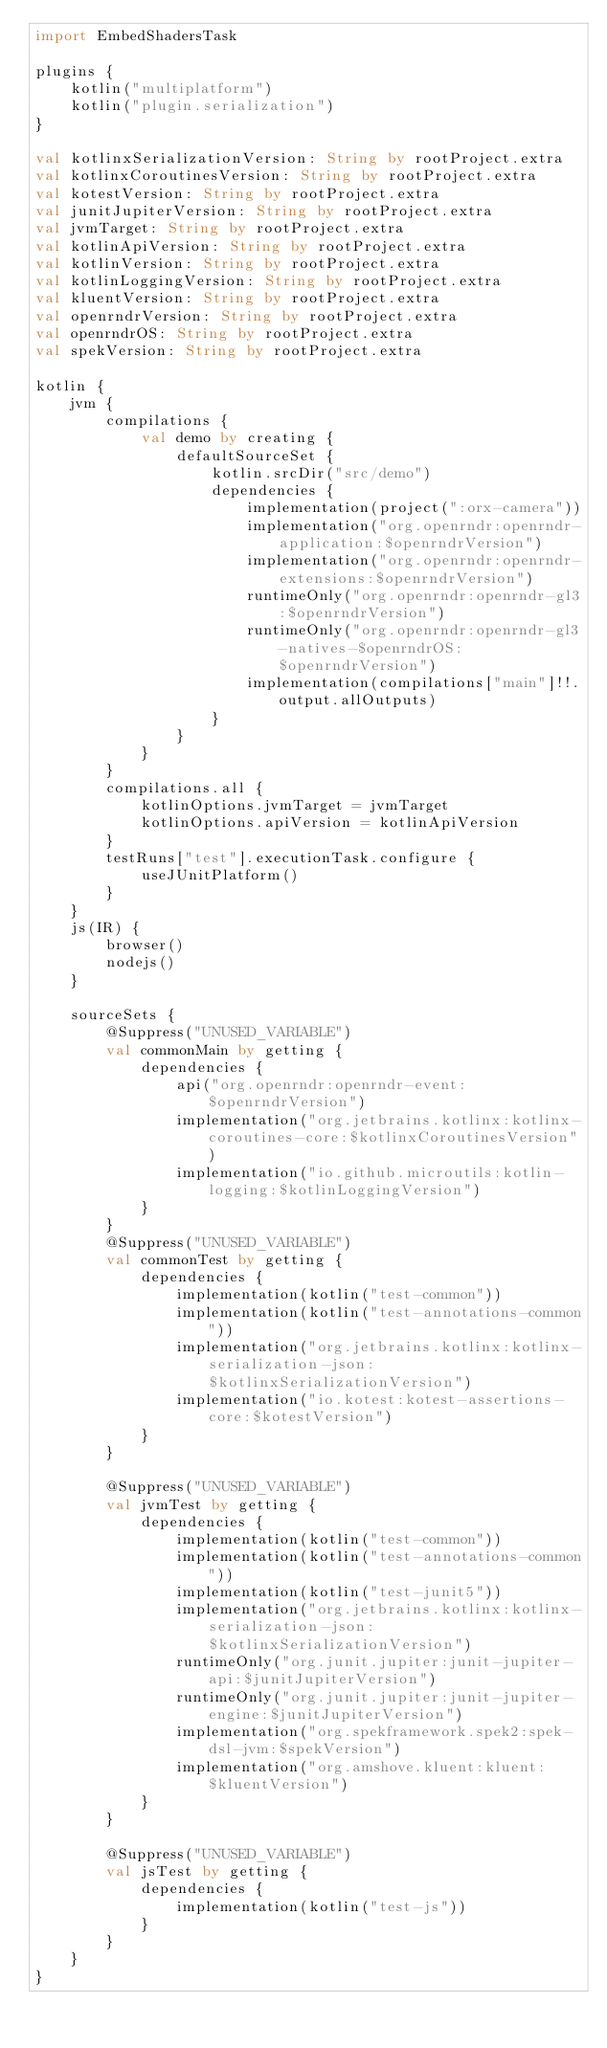<code> <loc_0><loc_0><loc_500><loc_500><_Kotlin_>import EmbedShadersTask

plugins {
    kotlin("multiplatform")
    kotlin("plugin.serialization")
}

val kotlinxSerializationVersion: String by rootProject.extra
val kotlinxCoroutinesVersion: String by rootProject.extra
val kotestVersion: String by rootProject.extra
val junitJupiterVersion: String by rootProject.extra
val jvmTarget: String by rootProject.extra
val kotlinApiVersion: String by rootProject.extra
val kotlinVersion: String by rootProject.extra
val kotlinLoggingVersion: String by rootProject.extra
val kluentVersion: String by rootProject.extra
val openrndrVersion: String by rootProject.extra
val openrndrOS: String by rootProject.extra
val spekVersion: String by rootProject.extra

kotlin {
    jvm {
        compilations {
            val demo by creating {
                defaultSourceSet {
                    kotlin.srcDir("src/demo")
                    dependencies {
                        implementation(project(":orx-camera"))
                        implementation("org.openrndr:openrndr-application:$openrndrVersion")
                        implementation("org.openrndr:openrndr-extensions:$openrndrVersion")
                        runtimeOnly("org.openrndr:openrndr-gl3:$openrndrVersion")
                        runtimeOnly("org.openrndr:openrndr-gl3-natives-$openrndrOS:$openrndrVersion")
                        implementation(compilations["main"]!!.output.allOutputs)
                    }
                }
            }
        }
        compilations.all {
            kotlinOptions.jvmTarget = jvmTarget
            kotlinOptions.apiVersion = kotlinApiVersion
        }
        testRuns["test"].executionTask.configure {
            useJUnitPlatform()
        }
    }
    js(IR) {
        browser()
        nodejs()
    }

    sourceSets {
        @Suppress("UNUSED_VARIABLE")
        val commonMain by getting {
            dependencies {
                api("org.openrndr:openrndr-event:$openrndrVersion")
                implementation("org.jetbrains.kotlinx:kotlinx-coroutines-core:$kotlinxCoroutinesVersion")
                implementation("io.github.microutils:kotlin-logging:$kotlinLoggingVersion")
            }
        }
        @Suppress("UNUSED_VARIABLE")
        val commonTest by getting {
            dependencies {
                implementation(kotlin("test-common"))
                implementation(kotlin("test-annotations-common"))
                implementation("org.jetbrains.kotlinx:kotlinx-serialization-json:$kotlinxSerializationVersion")
                implementation("io.kotest:kotest-assertions-core:$kotestVersion")
            }
        }

        @Suppress("UNUSED_VARIABLE")
        val jvmTest by getting {
            dependencies {
                implementation(kotlin("test-common"))
                implementation(kotlin("test-annotations-common"))
                implementation(kotlin("test-junit5"))
                implementation("org.jetbrains.kotlinx:kotlinx-serialization-json:$kotlinxSerializationVersion")
                runtimeOnly("org.junit.jupiter:junit-jupiter-api:$junitJupiterVersion")
                runtimeOnly("org.junit.jupiter:junit-jupiter-engine:$junitJupiterVersion")
                implementation("org.spekframework.spek2:spek-dsl-jvm:$spekVersion")
                implementation("org.amshove.kluent:kluent:$kluentVersion")
            }
        }

        @Suppress("UNUSED_VARIABLE")
        val jsTest by getting {
            dependencies {
                implementation(kotlin("test-js"))
            }
        }
    }
}</code> 